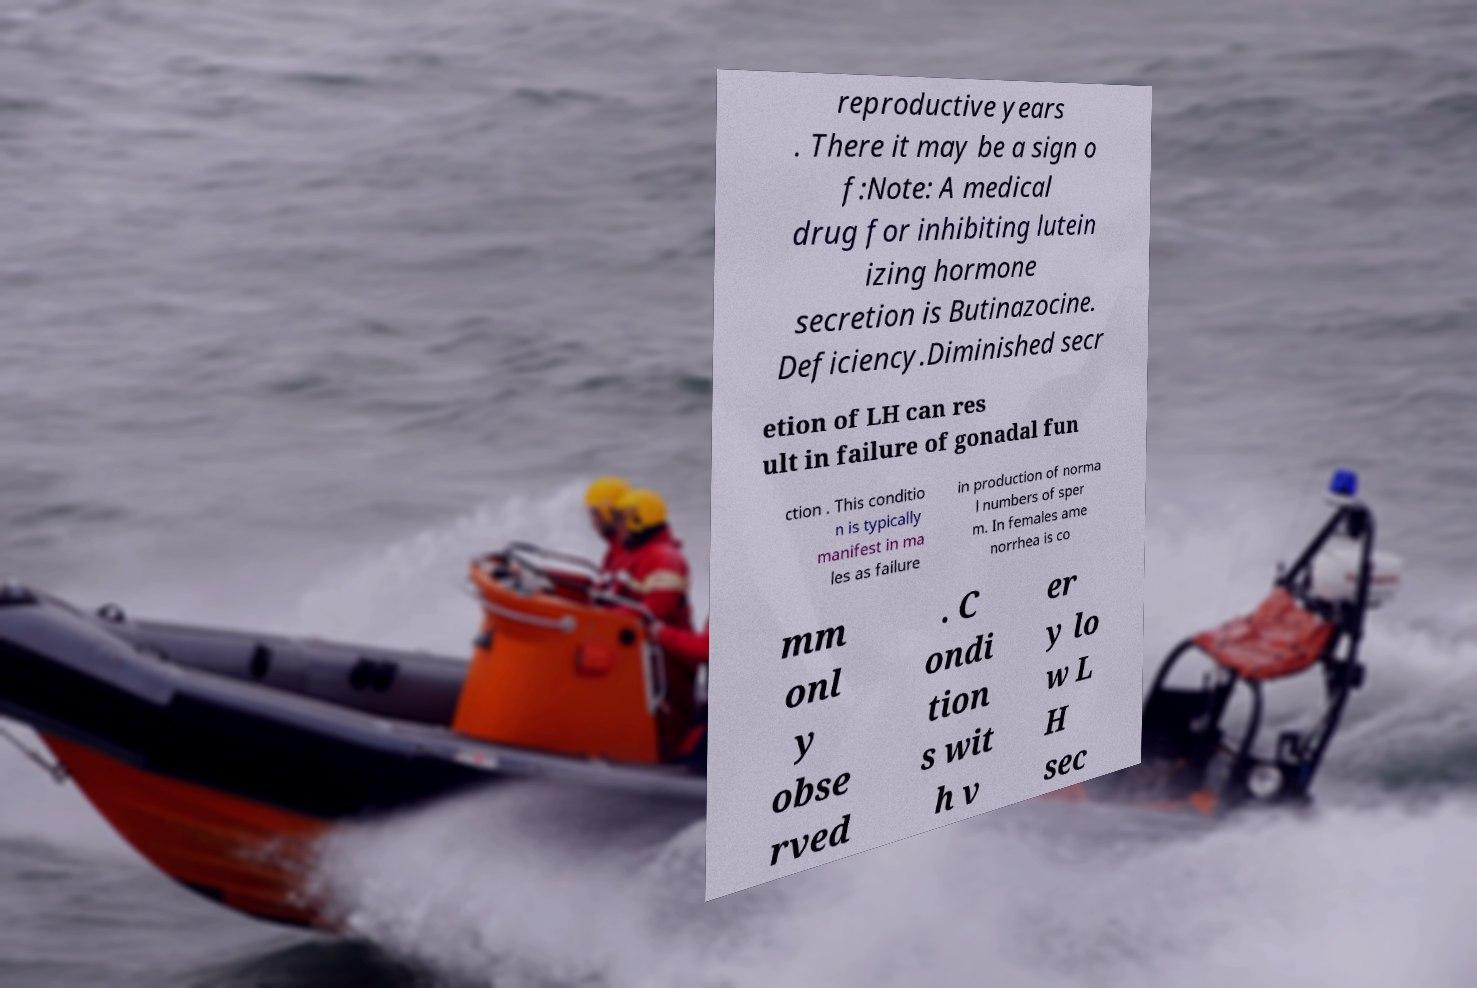There's text embedded in this image that I need extracted. Can you transcribe it verbatim? reproductive years . There it may be a sign o f:Note: A medical drug for inhibiting lutein izing hormone secretion is Butinazocine. Deficiency.Diminished secr etion of LH can res ult in failure of gonadal fun ction . This conditio n is typically manifest in ma les as failure in production of norma l numbers of sper m. In females ame norrhea is co mm onl y obse rved . C ondi tion s wit h v er y lo w L H sec 